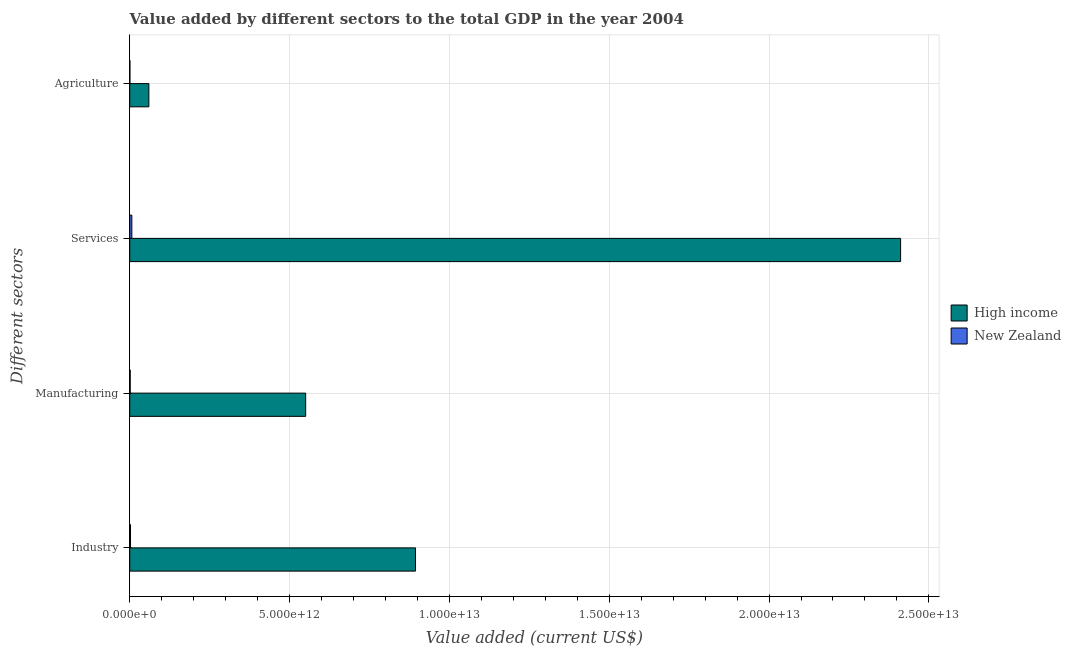How many different coloured bars are there?
Keep it short and to the point. 2. Are the number of bars per tick equal to the number of legend labels?
Ensure brevity in your answer.  Yes. Are the number of bars on each tick of the Y-axis equal?
Ensure brevity in your answer.  Yes. How many bars are there on the 2nd tick from the bottom?
Your answer should be compact. 2. What is the label of the 1st group of bars from the top?
Give a very brief answer. Agriculture. What is the value added by agricultural sector in High income?
Ensure brevity in your answer.  5.98e+11. Across all countries, what is the maximum value added by industrial sector?
Ensure brevity in your answer.  8.94e+12. Across all countries, what is the minimum value added by services sector?
Your answer should be compact. 6.65e+1. In which country was the value added by agricultural sector maximum?
Ensure brevity in your answer.  High income. In which country was the value added by industrial sector minimum?
Your answer should be compact. New Zealand. What is the total value added by industrial sector in the graph?
Your answer should be compact. 8.96e+12. What is the difference between the value added by industrial sector in High income and that in New Zealand?
Your answer should be compact. 8.91e+12. What is the difference between the value added by agricultural sector in New Zealand and the value added by services sector in High income?
Provide a succinct answer. -2.41e+13. What is the average value added by industrial sector per country?
Give a very brief answer. 4.48e+12. What is the difference between the value added by manufacturing sector and value added by agricultural sector in New Zealand?
Provide a succinct answer. 9.63e+09. What is the ratio of the value added by industrial sector in High income to that in New Zealand?
Keep it short and to the point. 364.13. Is the value added by industrial sector in High income less than that in New Zealand?
Provide a short and direct response. No. What is the difference between the highest and the second highest value added by services sector?
Provide a short and direct response. 2.40e+13. What is the difference between the highest and the lowest value added by agricultural sector?
Your response must be concise. 5.93e+11. Is the sum of the value added by industrial sector in New Zealand and High income greater than the maximum value added by manufacturing sector across all countries?
Keep it short and to the point. Yes. What does the 1st bar from the bottom in Manufacturing represents?
Make the answer very short. High income. How many bars are there?
Make the answer very short. 8. Are all the bars in the graph horizontal?
Offer a very short reply. Yes. How many countries are there in the graph?
Your response must be concise. 2. What is the difference between two consecutive major ticks on the X-axis?
Give a very brief answer. 5.00e+12. Are the values on the major ticks of X-axis written in scientific E-notation?
Your answer should be very brief. Yes. Does the graph contain grids?
Give a very brief answer. Yes. Where does the legend appear in the graph?
Provide a succinct answer. Center right. How are the legend labels stacked?
Keep it short and to the point. Vertical. What is the title of the graph?
Keep it short and to the point. Value added by different sectors to the total GDP in the year 2004. Does "Bolivia" appear as one of the legend labels in the graph?
Give a very brief answer. No. What is the label or title of the X-axis?
Make the answer very short. Value added (current US$). What is the label or title of the Y-axis?
Make the answer very short. Different sectors. What is the Value added (current US$) in High income in Industry?
Ensure brevity in your answer.  8.94e+12. What is the Value added (current US$) in New Zealand in Industry?
Offer a very short reply. 2.45e+1. What is the Value added (current US$) in High income in Manufacturing?
Offer a terse response. 5.50e+12. What is the Value added (current US$) in New Zealand in Manufacturing?
Offer a very short reply. 1.52e+1. What is the Value added (current US$) of High income in Services?
Offer a terse response. 2.41e+13. What is the Value added (current US$) of New Zealand in Services?
Make the answer very short. 6.65e+1. What is the Value added (current US$) in High income in Agriculture?
Keep it short and to the point. 5.98e+11. What is the Value added (current US$) in New Zealand in Agriculture?
Your answer should be very brief. 5.58e+09. Across all Different sectors, what is the maximum Value added (current US$) in High income?
Provide a succinct answer. 2.41e+13. Across all Different sectors, what is the maximum Value added (current US$) in New Zealand?
Offer a terse response. 6.65e+1. Across all Different sectors, what is the minimum Value added (current US$) in High income?
Offer a terse response. 5.98e+11. Across all Different sectors, what is the minimum Value added (current US$) in New Zealand?
Keep it short and to the point. 5.58e+09. What is the total Value added (current US$) in High income in the graph?
Offer a terse response. 3.92e+13. What is the total Value added (current US$) of New Zealand in the graph?
Offer a terse response. 1.12e+11. What is the difference between the Value added (current US$) in High income in Industry and that in Manufacturing?
Provide a succinct answer. 3.44e+12. What is the difference between the Value added (current US$) of New Zealand in Industry and that in Manufacturing?
Your response must be concise. 9.35e+09. What is the difference between the Value added (current US$) in High income in Industry and that in Services?
Offer a terse response. -1.52e+13. What is the difference between the Value added (current US$) in New Zealand in Industry and that in Services?
Your answer should be compact. -4.19e+1. What is the difference between the Value added (current US$) in High income in Industry and that in Agriculture?
Your answer should be compact. 8.34e+12. What is the difference between the Value added (current US$) in New Zealand in Industry and that in Agriculture?
Your response must be concise. 1.90e+1. What is the difference between the Value added (current US$) in High income in Manufacturing and that in Services?
Offer a very short reply. -1.86e+13. What is the difference between the Value added (current US$) of New Zealand in Manufacturing and that in Services?
Your answer should be compact. -5.13e+1. What is the difference between the Value added (current US$) in High income in Manufacturing and that in Agriculture?
Provide a succinct answer. 4.91e+12. What is the difference between the Value added (current US$) of New Zealand in Manufacturing and that in Agriculture?
Give a very brief answer. 9.63e+09. What is the difference between the Value added (current US$) of High income in Services and that in Agriculture?
Your answer should be very brief. 2.35e+13. What is the difference between the Value added (current US$) in New Zealand in Services and that in Agriculture?
Keep it short and to the point. 6.09e+1. What is the difference between the Value added (current US$) of High income in Industry and the Value added (current US$) of New Zealand in Manufacturing?
Your answer should be very brief. 8.92e+12. What is the difference between the Value added (current US$) of High income in Industry and the Value added (current US$) of New Zealand in Services?
Ensure brevity in your answer.  8.87e+12. What is the difference between the Value added (current US$) of High income in Industry and the Value added (current US$) of New Zealand in Agriculture?
Offer a terse response. 8.93e+12. What is the difference between the Value added (current US$) of High income in Manufacturing and the Value added (current US$) of New Zealand in Services?
Provide a short and direct response. 5.44e+12. What is the difference between the Value added (current US$) of High income in Manufacturing and the Value added (current US$) of New Zealand in Agriculture?
Make the answer very short. 5.50e+12. What is the difference between the Value added (current US$) in High income in Services and the Value added (current US$) in New Zealand in Agriculture?
Keep it short and to the point. 2.41e+13. What is the average Value added (current US$) of High income per Different sectors?
Give a very brief answer. 9.79e+12. What is the average Value added (current US$) of New Zealand per Different sectors?
Provide a short and direct response. 2.79e+1. What is the difference between the Value added (current US$) in High income and Value added (current US$) in New Zealand in Industry?
Offer a terse response. 8.91e+12. What is the difference between the Value added (current US$) in High income and Value added (current US$) in New Zealand in Manufacturing?
Offer a terse response. 5.49e+12. What is the difference between the Value added (current US$) in High income and Value added (current US$) in New Zealand in Services?
Your answer should be compact. 2.40e+13. What is the difference between the Value added (current US$) of High income and Value added (current US$) of New Zealand in Agriculture?
Ensure brevity in your answer.  5.93e+11. What is the ratio of the Value added (current US$) in High income in Industry to that in Manufacturing?
Keep it short and to the point. 1.62. What is the ratio of the Value added (current US$) of New Zealand in Industry to that in Manufacturing?
Provide a short and direct response. 1.61. What is the ratio of the Value added (current US$) in High income in Industry to that in Services?
Provide a succinct answer. 0.37. What is the ratio of the Value added (current US$) in New Zealand in Industry to that in Services?
Keep it short and to the point. 0.37. What is the ratio of the Value added (current US$) in High income in Industry to that in Agriculture?
Your response must be concise. 14.94. What is the ratio of the Value added (current US$) of New Zealand in Industry to that in Agriculture?
Provide a succinct answer. 4.4. What is the ratio of the Value added (current US$) of High income in Manufacturing to that in Services?
Offer a very short reply. 0.23. What is the ratio of the Value added (current US$) in New Zealand in Manufacturing to that in Services?
Offer a very short reply. 0.23. What is the ratio of the Value added (current US$) of High income in Manufacturing to that in Agriculture?
Provide a succinct answer. 9.2. What is the ratio of the Value added (current US$) of New Zealand in Manufacturing to that in Agriculture?
Offer a terse response. 2.73. What is the ratio of the Value added (current US$) in High income in Services to that in Agriculture?
Your answer should be very brief. 40.3. What is the ratio of the Value added (current US$) of New Zealand in Services to that in Agriculture?
Ensure brevity in your answer.  11.92. What is the difference between the highest and the second highest Value added (current US$) of High income?
Keep it short and to the point. 1.52e+13. What is the difference between the highest and the second highest Value added (current US$) of New Zealand?
Ensure brevity in your answer.  4.19e+1. What is the difference between the highest and the lowest Value added (current US$) of High income?
Make the answer very short. 2.35e+13. What is the difference between the highest and the lowest Value added (current US$) in New Zealand?
Your answer should be very brief. 6.09e+1. 